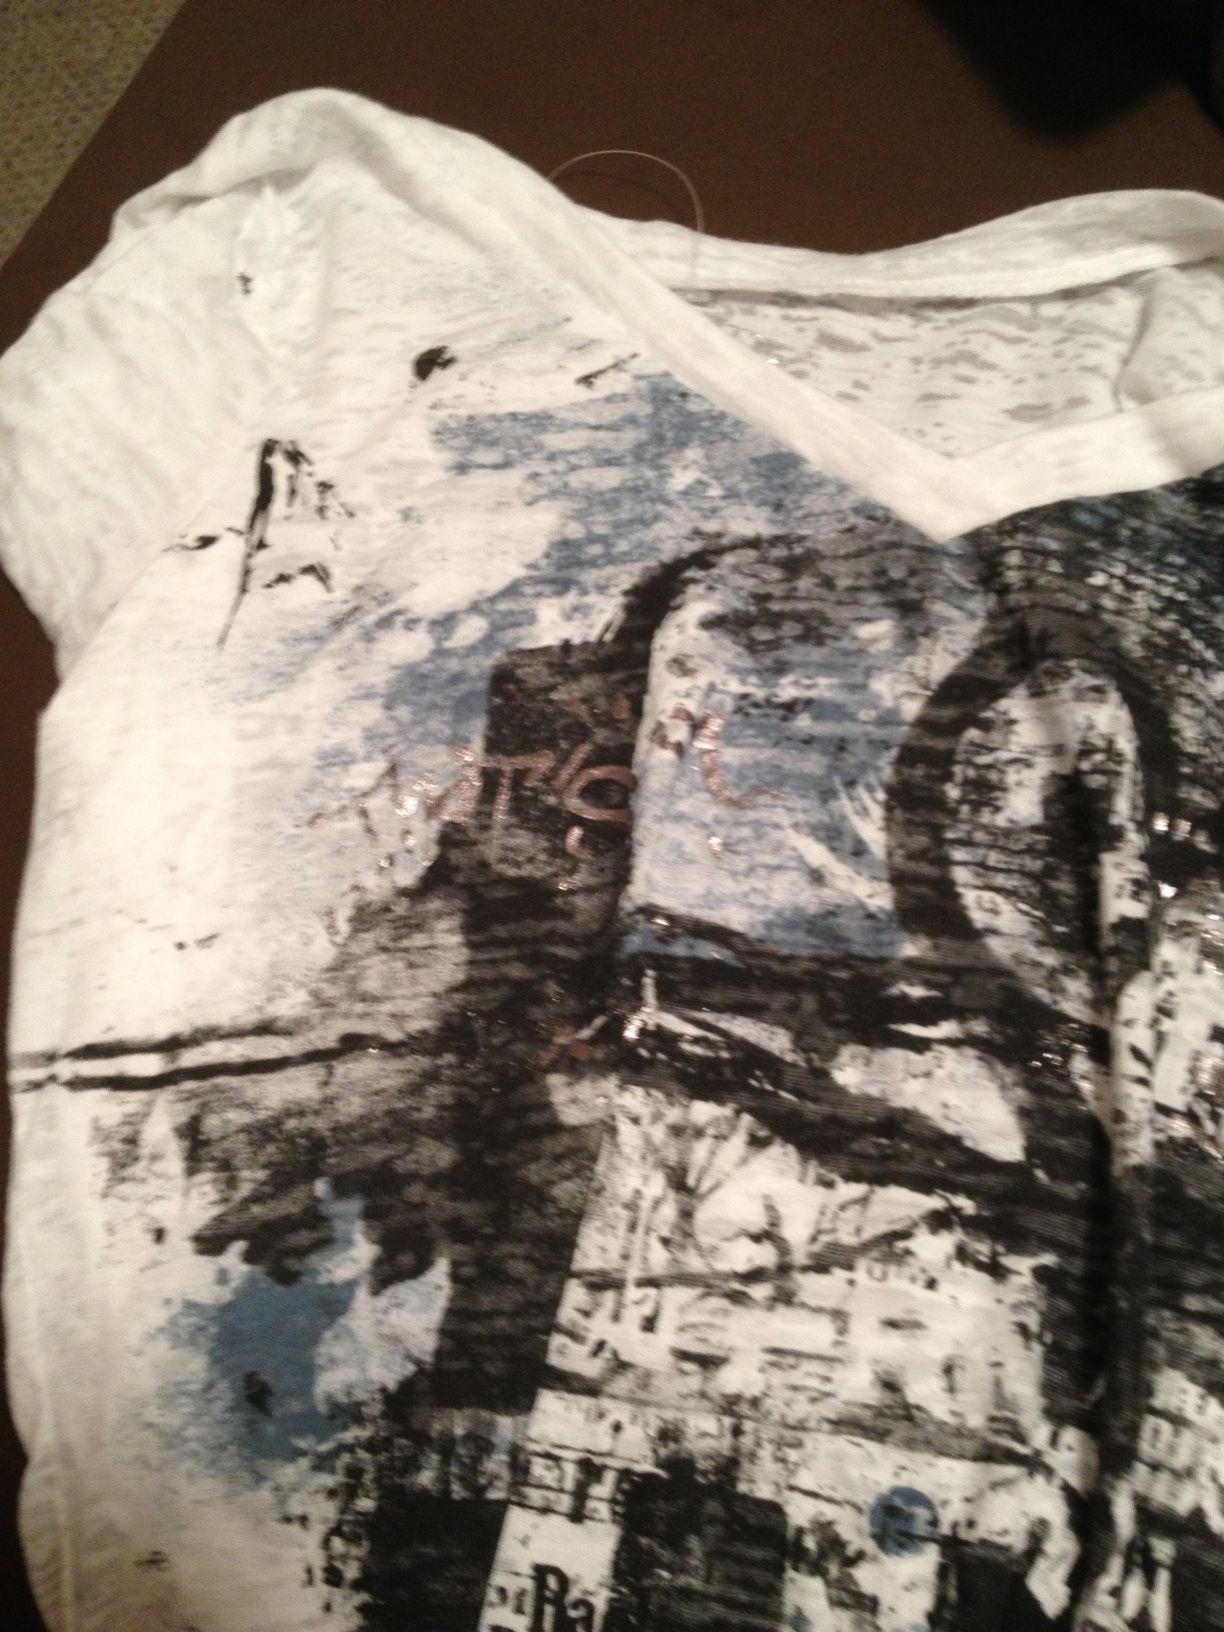Describe the colors and textures on this shirt in detail. The shirt has a predominantly white base with a blend of black and blue abstract patterns. The black strokes seem to mimic brush strokes, adding a dynamic and edgy feel. The blue areas provide a softer contrast, blending in with the overall distressed look of the fabric. There are faint hints of another darker color, possibly brown, adding depth to the design. 